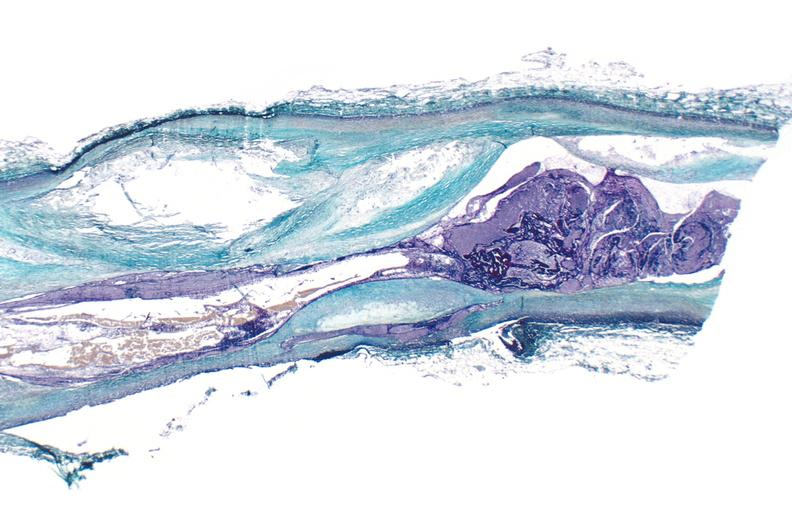does palmar crease normal show coronary artery atherosclerosis, thrombosis longitudinal section?
Answer the question using a single word or phrase. No 